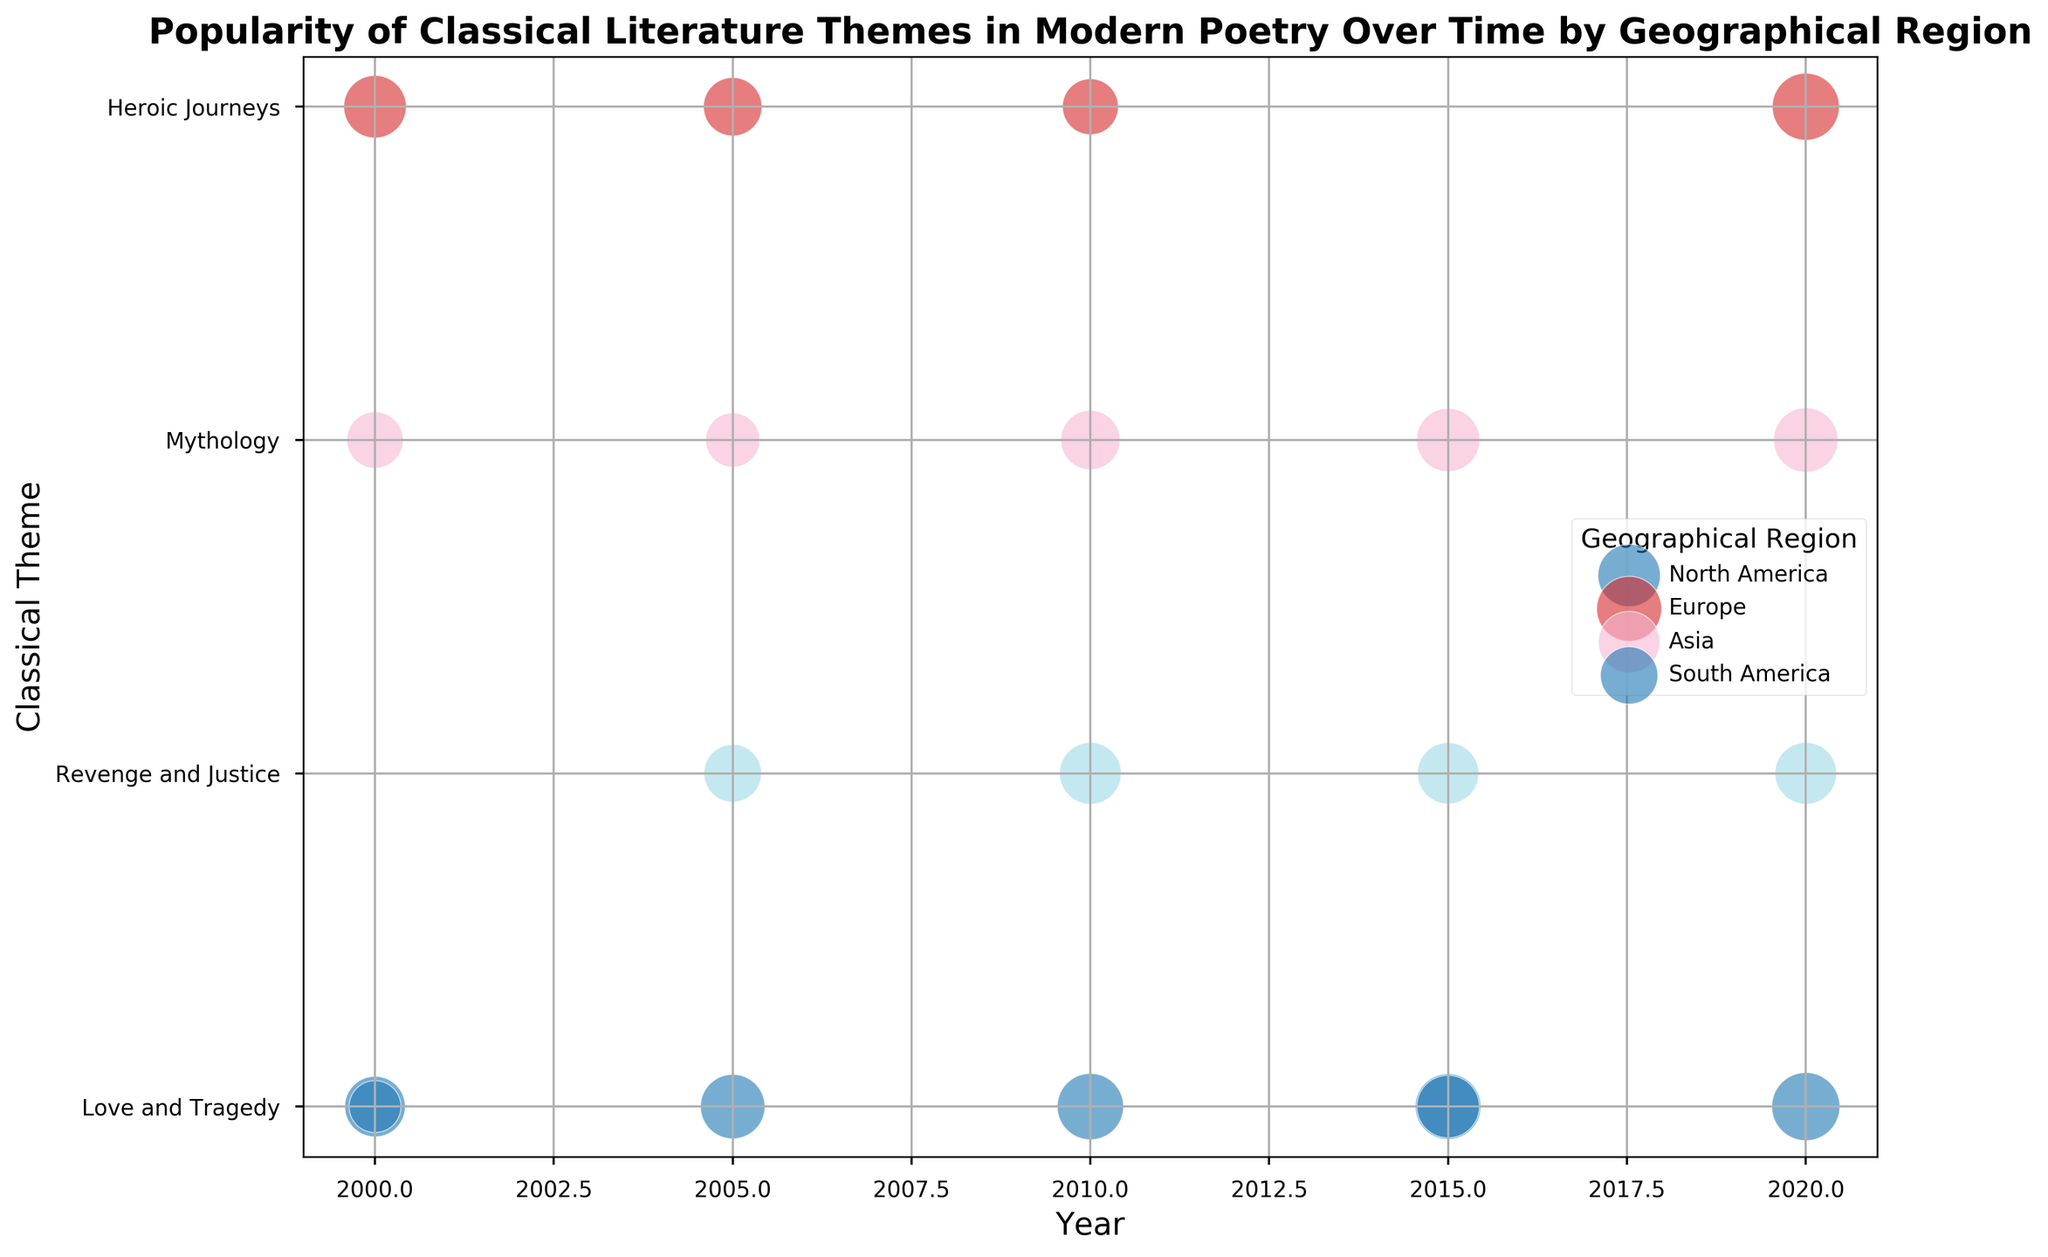How many geographical regions have "Love and Tragedy" as the most popular theme in 2020? In the year 2020, check which regions' bubbles are mapped to "Love and Tragedy" and compare their sizes with other themes in the same year. Only Europe has "Love and Tragedy" as the theme with the largest bubble, indicating it is the most popular theme.
Answer: One What are the themes that have consistently increased in popularity in North America from 2000 to 2020? Look at North America's bubbles from year 2000 to 2020. The themes "Love and Tragedy," "Revenge and Justice," and "Heroic Journeys" have bubbles that consistently grow larger over time.
Answer: Love and Tragedy, Revenge and Justice, Heroic Journeys Which geographical region had the highest popularity score for "Heroic Journeys" in 2020? Compare the sizes of bubbles for "Heroic Journeys" in the year 2020 across all regions. North America has the largest bubble for this theme.
Answer: North America Between 2015 and 2020, which theme in South America saw the highest increase in popularity score? Compare the bubble sizes of themes in South America between 2015 and 2020. "Revenge and Justice" shows the most significant increase in bubble size, from none in 2015 to a sizeable bubble in 2020.
Answer: Revenge and Justice What is the trend in popularity of "Mythology" in Asia from 2000 to 2020? Look at the "Mythology" bubbles in Asia for each year. The sizes of the bubbles indicate that the popularity increases over time from 65 in 2000 to 85 in 2020.
Answer: Increasing Which region had the lowest popularity score for "Love and Tragedy" in 2005? Compare the bubble sizes of "Love and Tragedy" in 2005 across all regions. South America has the smallest bubble for this theme.
Answer: South America In which year did Europe have the most interest in "Mythology"? Check the bubble sizes across multiple years for "Mythology" in Europe. The largest bubble appears in 2015, representing the highest popularity score.
Answer: 2015 Which classical theme appears the most during the two-decade period in Asia? Count the occurrences of each classical theme's bubbles in Asia from 2000 to 2020. "Mythology," "Heroic Journeys," and "Love and Tragedy" all appear multiple times, but "Mythology" shows a consistent presence in more years.
Answer: Mythology How does the popularity of "Heroic Journeys" in Europe in 2000 compare with that in South America in 2010? Compare the bubble sizes for "Heroic Journeys" in Europe in 2000 and South America in 2010. Europe's bubble is larger than South America's, indicating higher popularity in Europe.
Answer: More popular in Europe What is the average popularity score of "Revenge and Justice" across all regions in 2010? Add up the popularity scores of "Revenge and Justice" across regions in 2010 (only one, 78) and divide by the number of occurrences (1). The average is 78.
Answer: 78 